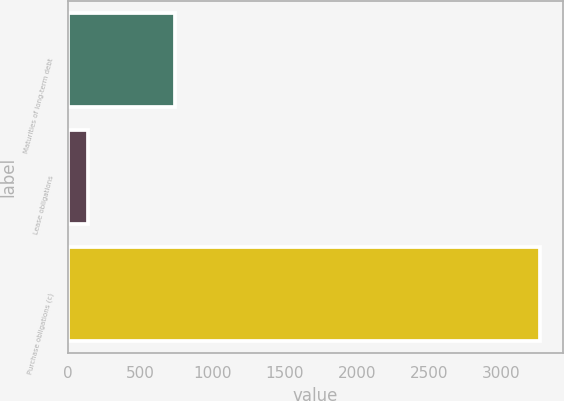Convert chart to OTSL. <chart><loc_0><loc_0><loc_500><loc_500><bar_chart><fcel>Maturities of long-term debt<fcel>Lease obligations<fcel>Purchase obligations (c)<nl><fcel>742<fcel>142<fcel>3266<nl></chart> 